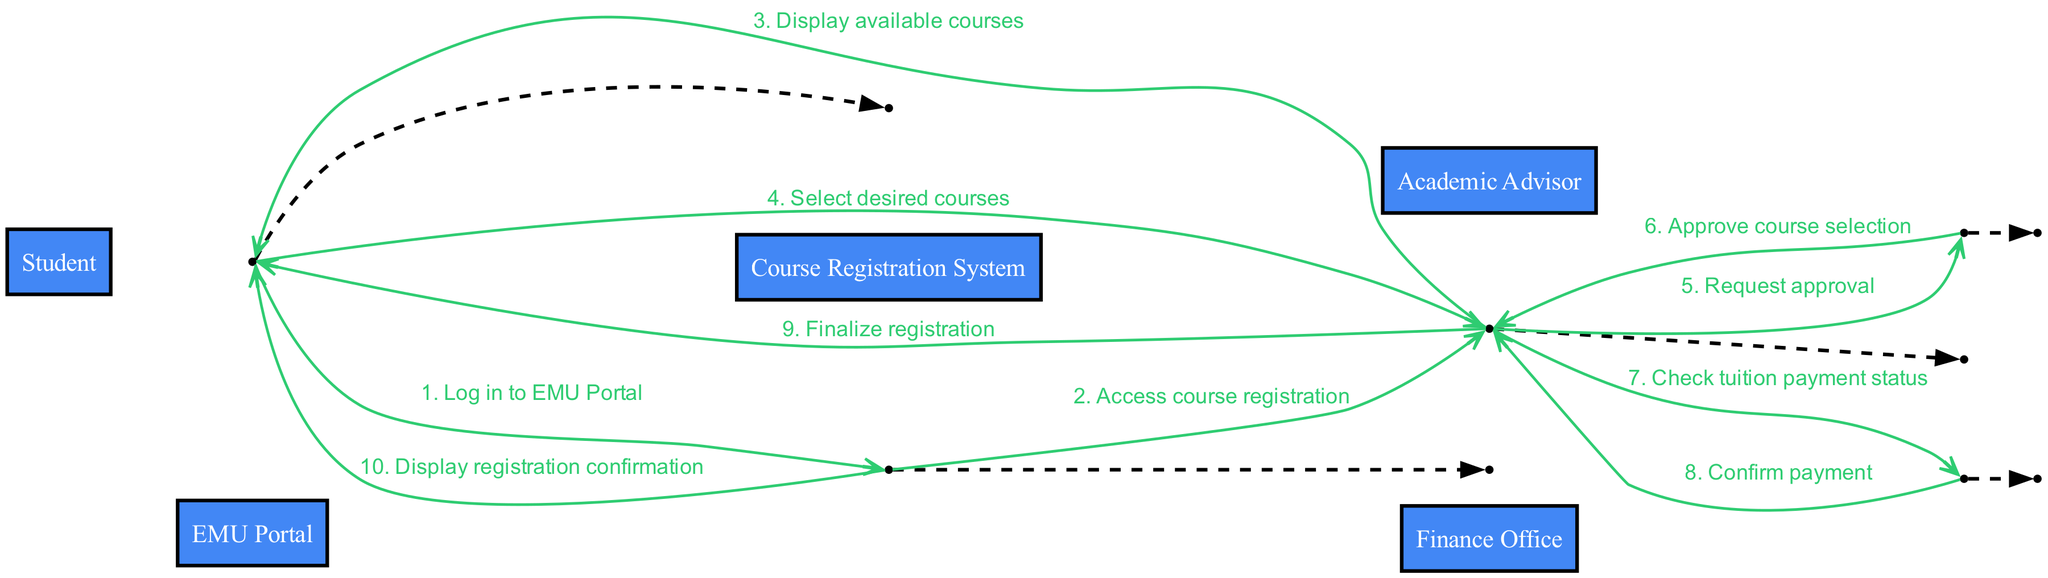What is the first action taken by the Student? The first action taken by the Student is to log into the EMU Portal. This is the first message sent from the Student to the EMU Portal.
Answer: Log in to EMU Portal How many actors are involved in the course registration process? There are five actors involved in the course registration process: Student, EMU Portal, Course Registration System, Academic Advisor, and Finance Office. Each actor represents a role or system that participates in the flow, and they can be counted directly.
Answer: Five What is the last action performed by the Course Registration System? The last action performed by the Course Registration System is to finalize the registration, which is the final message in the sequence that goes from the Course Registration System to the Student.
Answer: Finalize registration How many total messages are exchanged in the diagram? A total of ten messages are exchanged in the diagram, which can be counted directly by reviewing the full list of messages that flow between the actors.
Answer: Ten Who approves the course selection? The Academic Advisor approves the course selection, as indicated in the message from the Academic Advisor back to the Course Registration System after a request for approval is made.
Answer: Academic Advisor What is the relationship between the Course Registration System and the Finance Office? The relationship involves a check of the tuition payment status, where the Course Registration System seeks confirmation from the Finance Office regarding the payment status before finalizing the registration.
Answer: Check tuition payment status Before the Student finalizes registration, which step must occur? Before finalizing registration, the Course Registration System must check and receive confirmation of the tuition payment status from the Finance Office. This step is crucial for allowing the registration to be processed.
Answer: Check tuition payment status Which action requires an approval? The action that requires approval is the selection of desired courses by the Student, which triggers a request for approval to the Academic Advisor. The process must be approved before moving forward.
Answer: Request approval How many messages are sent from the EMU Portal to the Student? There are two messages sent from the EMU Portal to the Student: first for accessing course registration, and the second for displaying the registration confirmation after finalizing the registration.
Answer: Two 